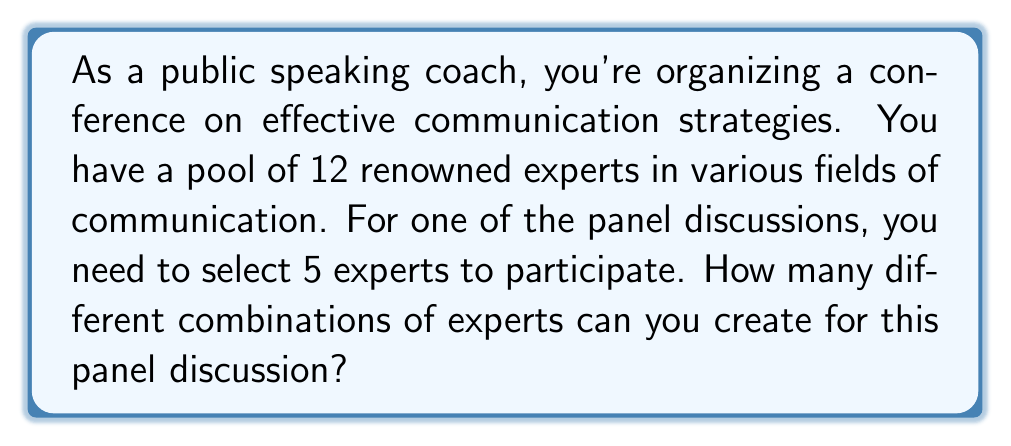Show me your answer to this math problem. Let's approach this step-by-step:

1) This is a combination problem because:
   - The order of selection doesn't matter (it's the same panel regardless of the order experts are chosen)
   - We're selecting a subset (5) from a larger group (12)
   - Each expert can only be selected once

2) The formula for combinations is:

   $$ C(n,r) = \frac{n!}{r!(n-r)!} $$

   Where $n$ is the total number of items to choose from, and $r$ is the number of items being chosen.

3) In this case:
   $n = 12$ (total number of experts)
   $r = 5$ (number of experts needed for the panel)

4) Let's substitute these values into our formula:

   $$ C(12,5) = \frac{12!}{5!(12-5)!} = \frac{12!}{5!(7)!} $$

5) Expand this:
   $$ \frac{12 * 11 * 10 * 9 * 8 * 7!}{(5 * 4 * 3 * 2 * 1) * 7!} $$

6) The 7! cancels out in the numerator and denominator:
   $$ \frac{12 * 11 * 10 * 9 * 8}{5 * 4 * 3 * 2 * 1} $$

7) Multiply the numerator and denominator:
   $$ \frac{95,040}{120} = 792 $$

Therefore, there are 792 different possible combinations for the panel discussion.
Answer: 792 